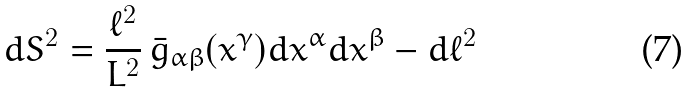<formula> <loc_0><loc_0><loc_500><loc_500>d S ^ { 2 } = \frac { \ell ^ { 2 } } { L ^ { 2 } } \, \bar { g } _ { \alpha \beta } ( x ^ { \gamma } ) d x ^ { \alpha } d x ^ { \beta } - d \ell ^ { 2 } \,</formula> 